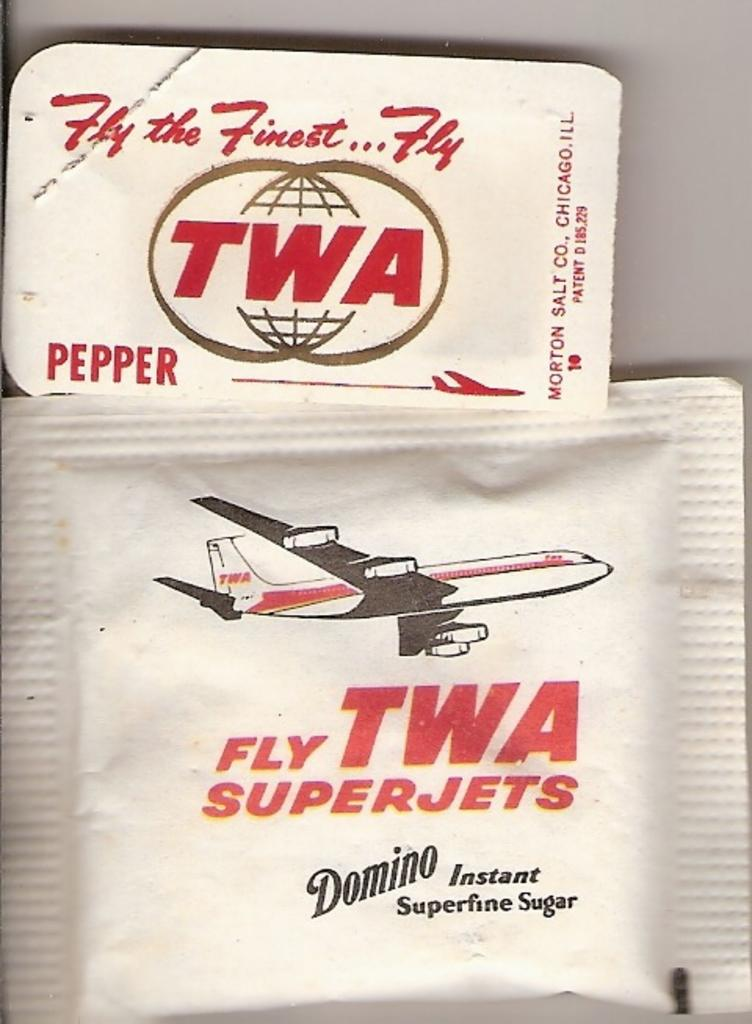<image>
Relay a brief, clear account of the picture shown. Instant Superfine Sugar packages for TWA Superjets on a table. 